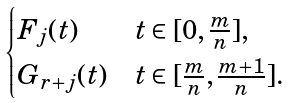Convert formula to latex. <formula><loc_0><loc_0><loc_500><loc_500>\begin{cases} F _ { j } ( t ) & t \in [ 0 , \frac { m } { n } ] , \\ G _ { r + j } ( t ) & t \in [ \frac { m } { n } , \frac { m + 1 } n ] . \end{cases}</formula> 